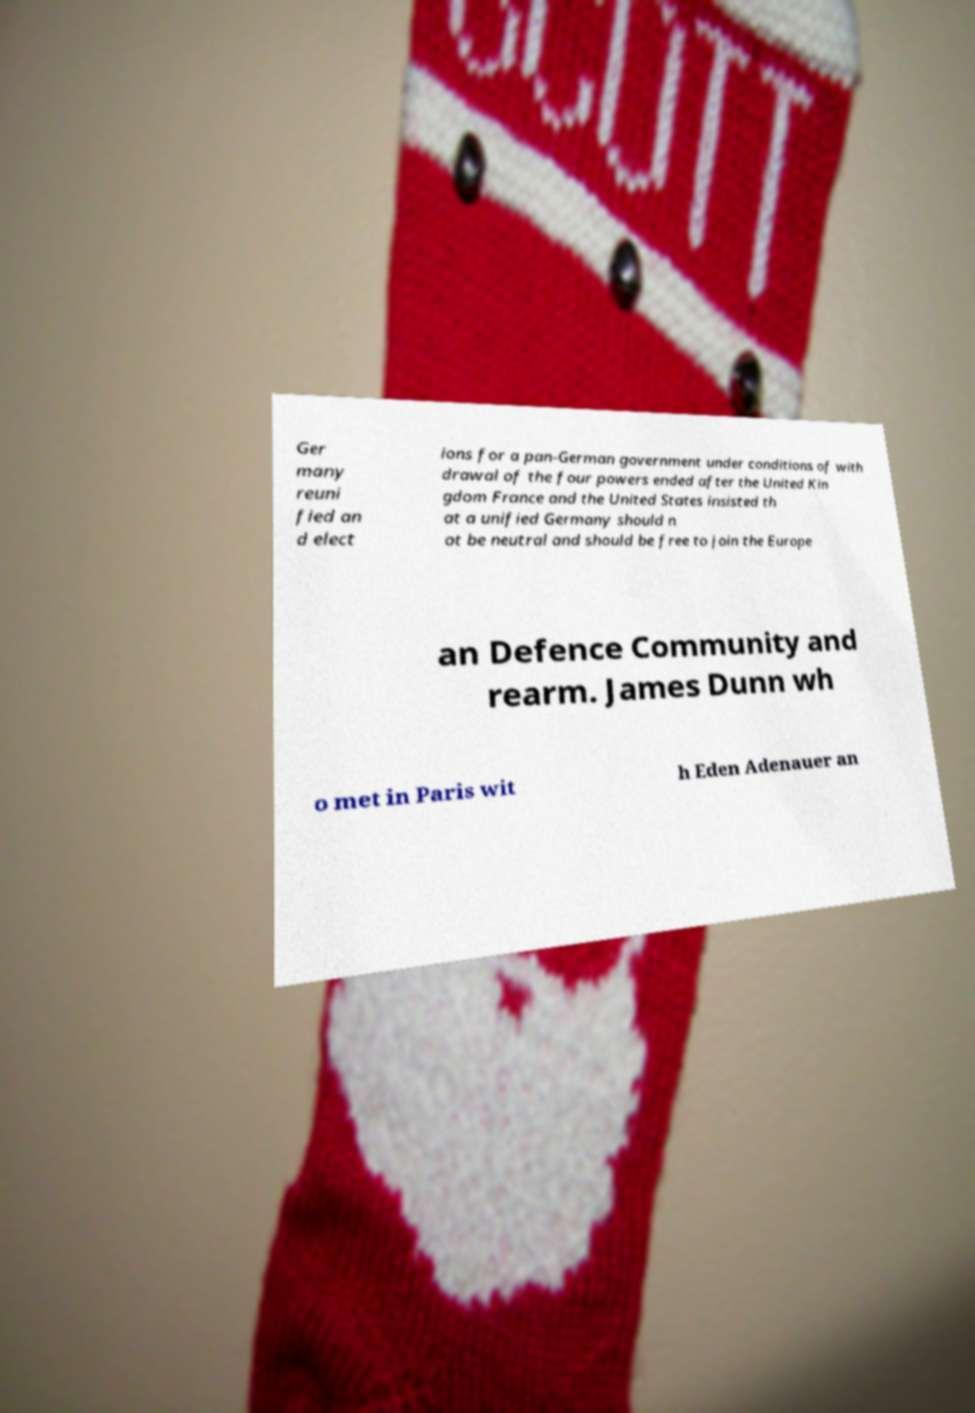Please identify and transcribe the text found in this image. Ger many reuni fied an d elect ions for a pan-German government under conditions of with drawal of the four powers ended after the United Kin gdom France and the United States insisted th at a unified Germany should n ot be neutral and should be free to join the Europe an Defence Community and rearm. James Dunn wh o met in Paris wit h Eden Adenauer an 